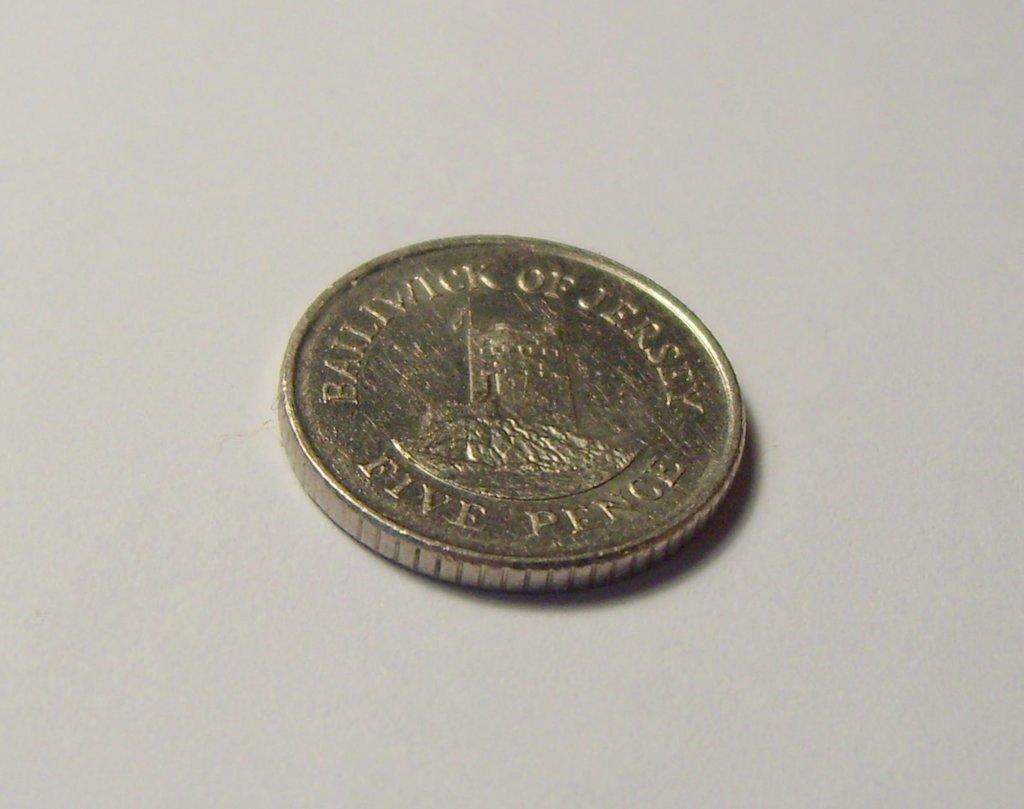<image>
Render a clear and concise summary of the photo. A silver coin from jersey is worth five pence. 